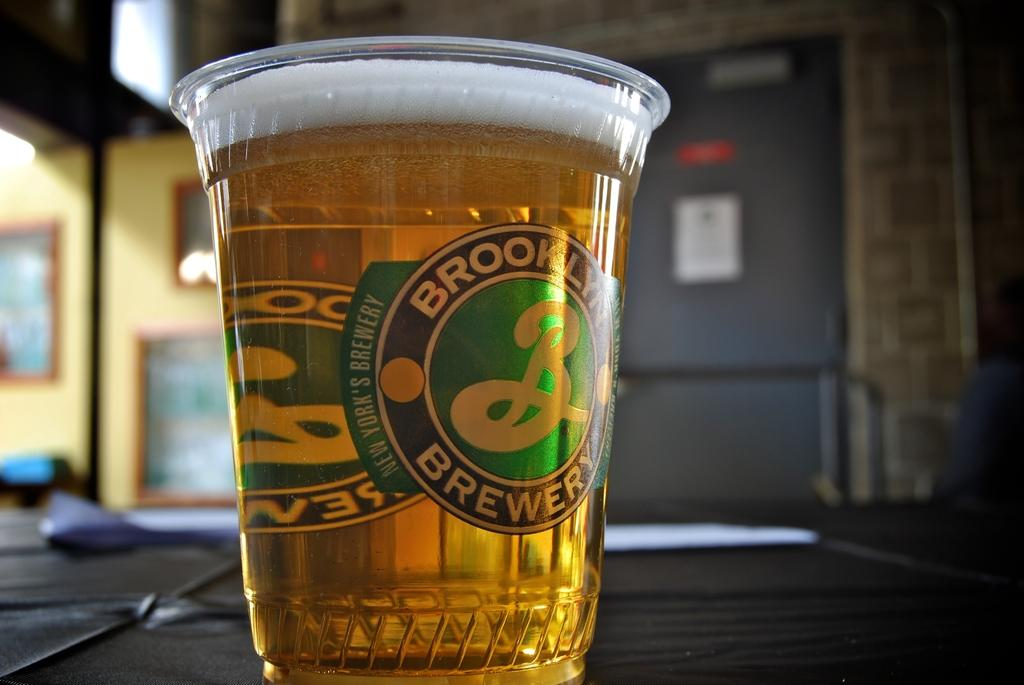<image>
Provide a brief description of the given image. Brooklyn Brewery has a cup which beer can be served in. 